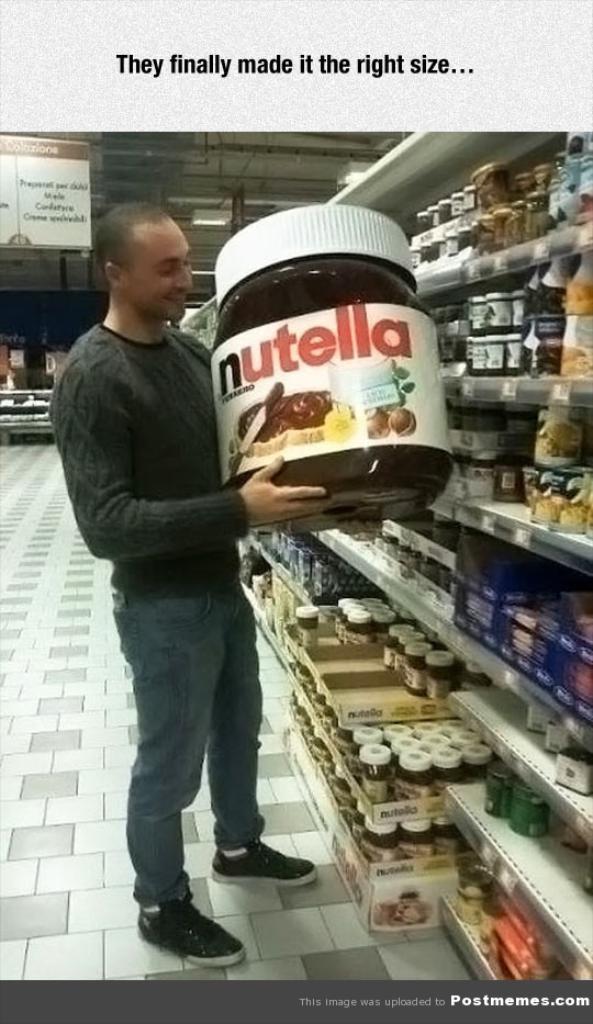What brand of spread is the man buying?
Your response must be concise. Nutella. What is the caption of this photo?
Offer a very short reply. They finally made it the right size. 